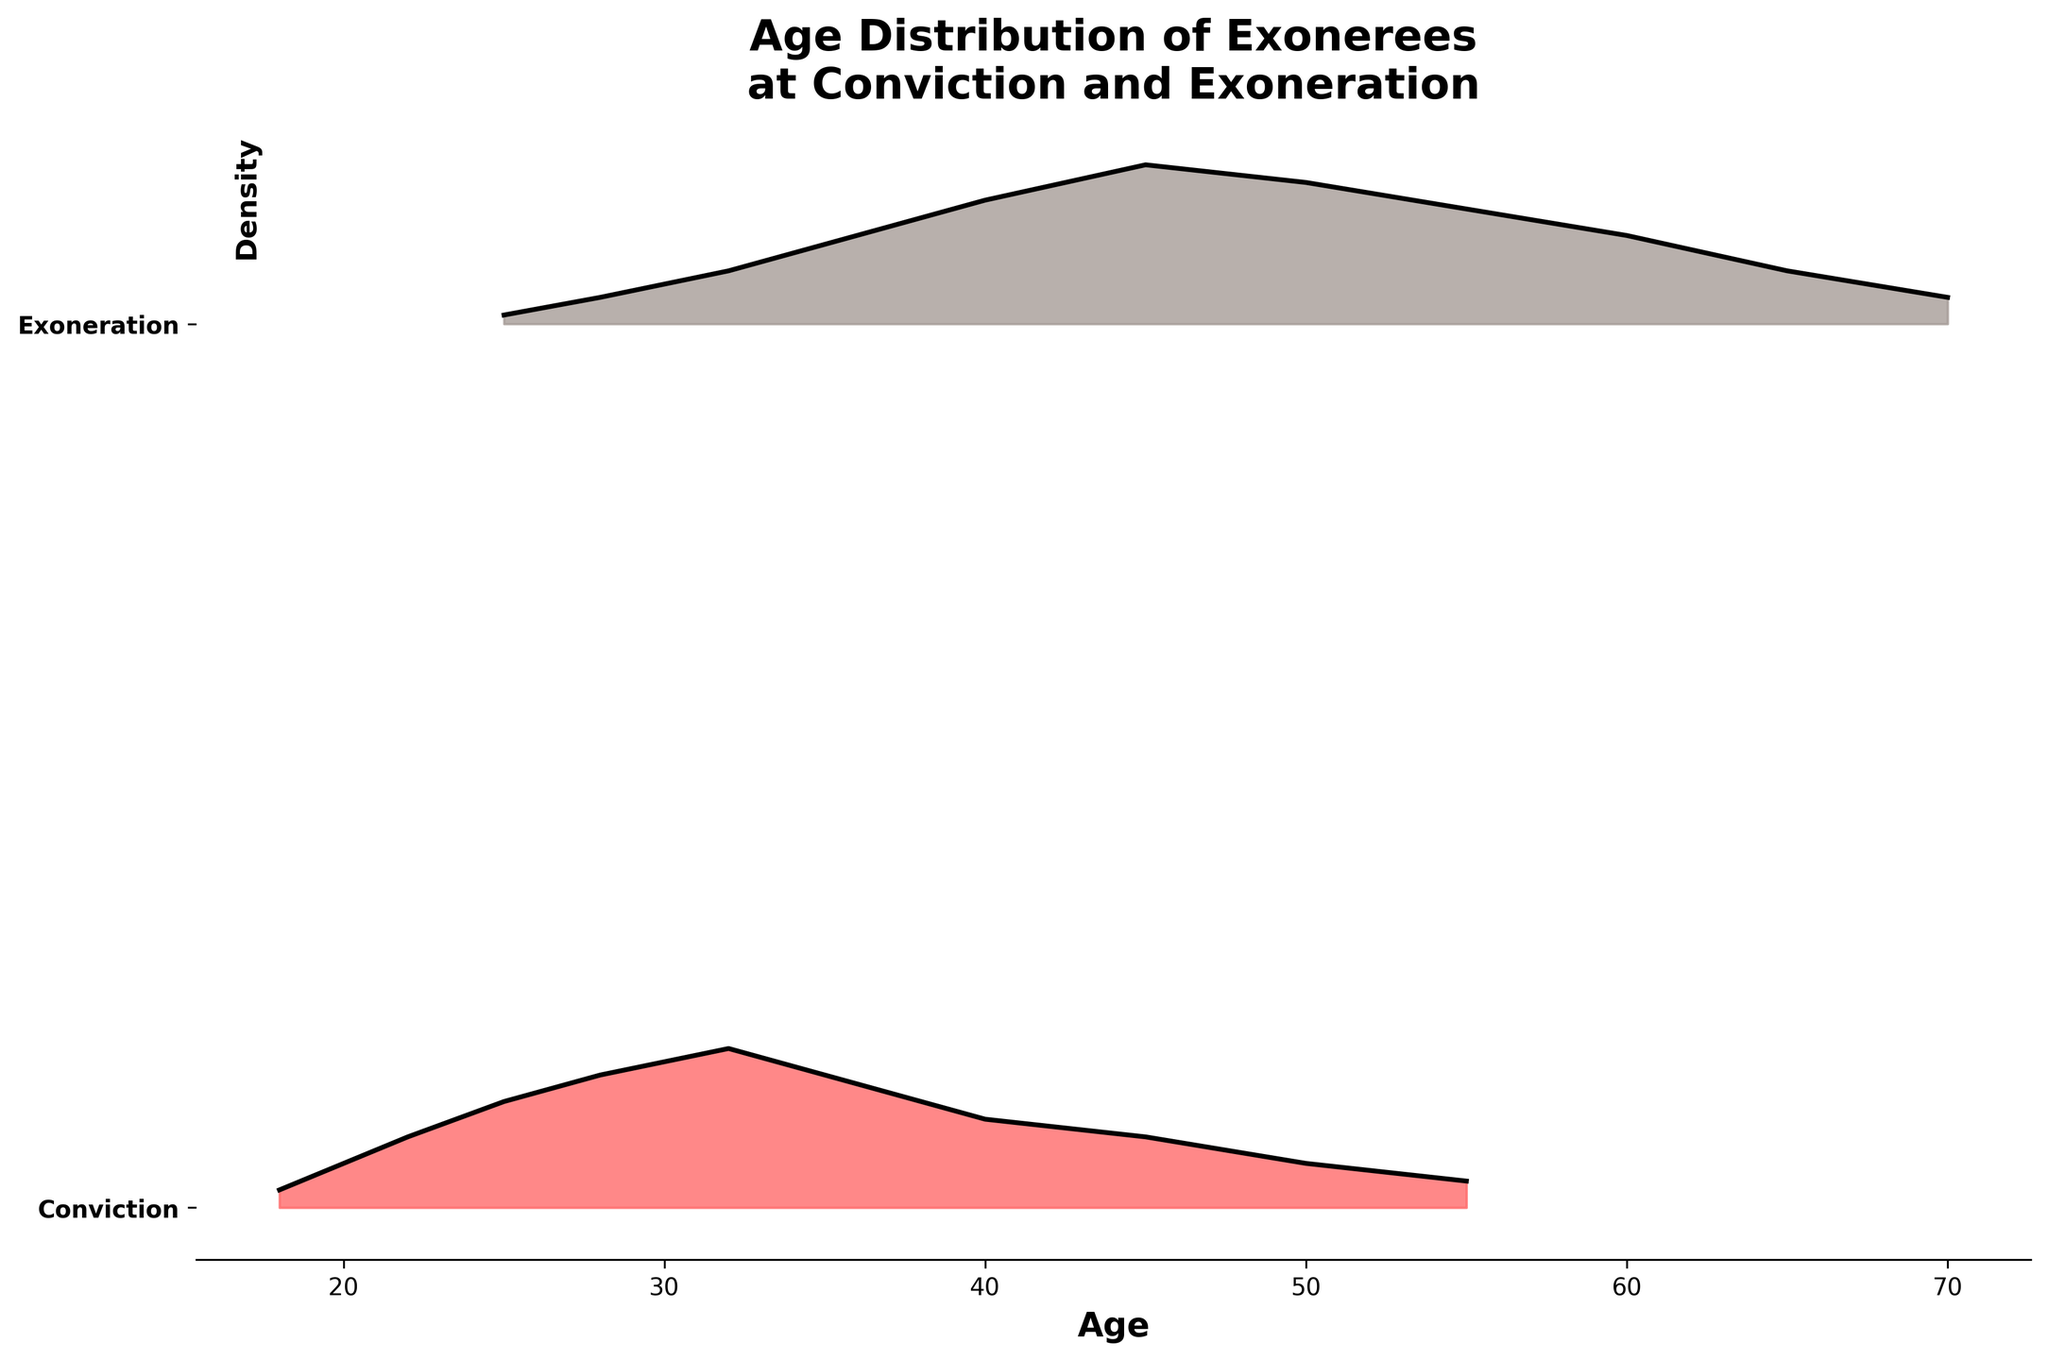What's the title of the plot? The title is located at the top of the plot and is clearly written.
Answer: Age Distribution of Exonerees at Conviction and Exoneration What is the x-axis label? The x-axis label is written below the horizontal axis of the plot.
Answer: Age How many categories are shown in the plot? There are two distinct y-axis labels which represent the categories.
Answer: Two In what age range is the density highest for convictions? The highest density for convictions can be observed around where the curve hits its peak above the x-axis.
Answer: 32 years What is the age range where exonerations are most frequent? The highest density for exonerations is where the peak of the exoneration curve is located above the x-axis.
Answer: 45 years Which category has a peak density at a higher age, Conviction or Exoneration? Comparing the positions of the peaks in both categories, the Exoneration category's peak is at a higher age than the Conviction category's peak.
Answer: Exoneration How does the shape of the density distribution differ between convictions and exonerations? The Conviction category has an early peak, and the density decreases as age increases, while the Exoneration category peaks at an older age and decreases gradually.
Answer: Convictions peak earlier, Exonerations peak later What is the approximate density value for exonerations at age 45? At age 45 on the x-axis, the height of the curve above the y-axis marks the density value.
Answer: 0.18 How does the density of exonerees at age 50 compare between Conviction and Exoneration? For age 50 on the x-axis, comparing the heights of the curves at this point for both categories reveals the relative densities.
Answer: Conviction: 0.05, Exoneration: 0.16 